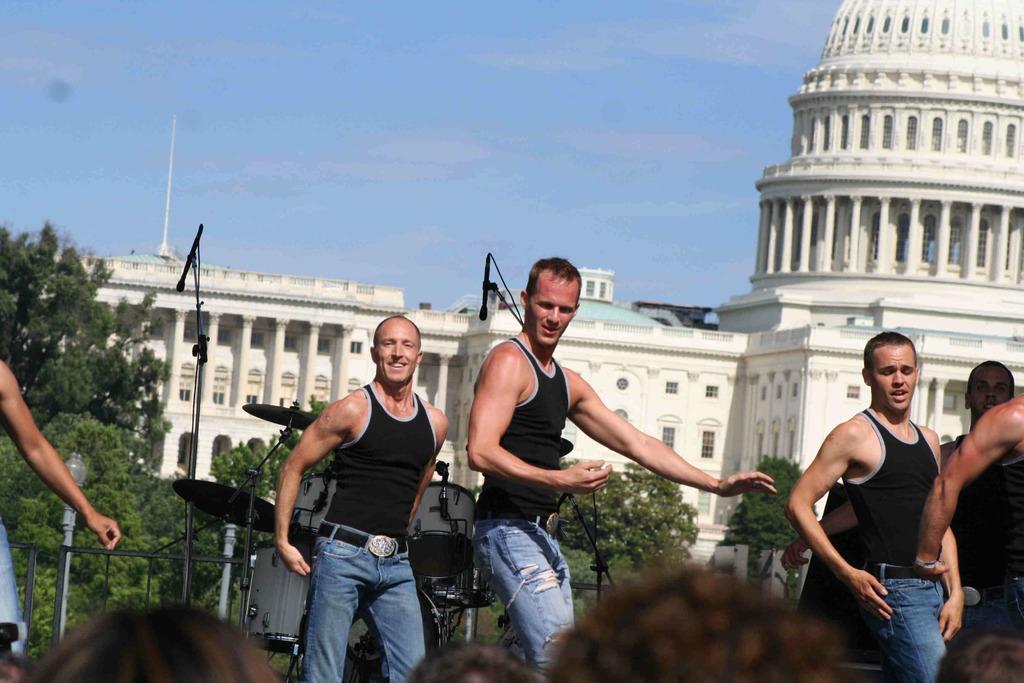How would you summarize this image in a sentence or two? Here we can see people. Backside of them there are musical instruments, light poles, grill, mics with stand, trees, building and sky. To that building there are pillars and windows.  